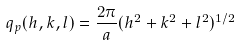<formula> <loc_0><loc_0><loc_500><loc_500>q _ { p } ( h , k , l ) = \frac { 2 \pi } { a } ( h ^ { 2 } + k ^ { 2 } + l ^ { 2 } ) ^ { 1 / 2 }</formula> 